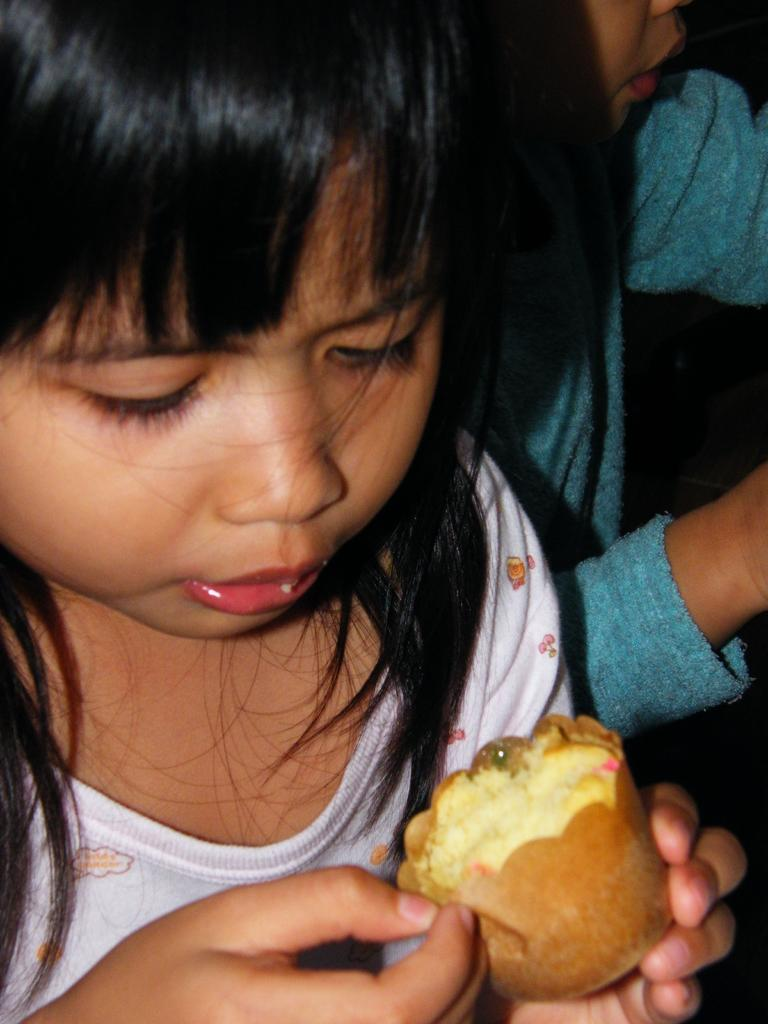Who is the main subject in the image? There is a girl in the image. What is the girl holding in the image? The girl is holding a cupcake with a paper. Are there any other children in the image? Yes, there is another kid on the right side of the image. What type of stone can be seen on the left side of the image? There is no stone present in the image. Can you tell me how many mailboxes are visible in the image? There are no mailboxes visible in the image. 